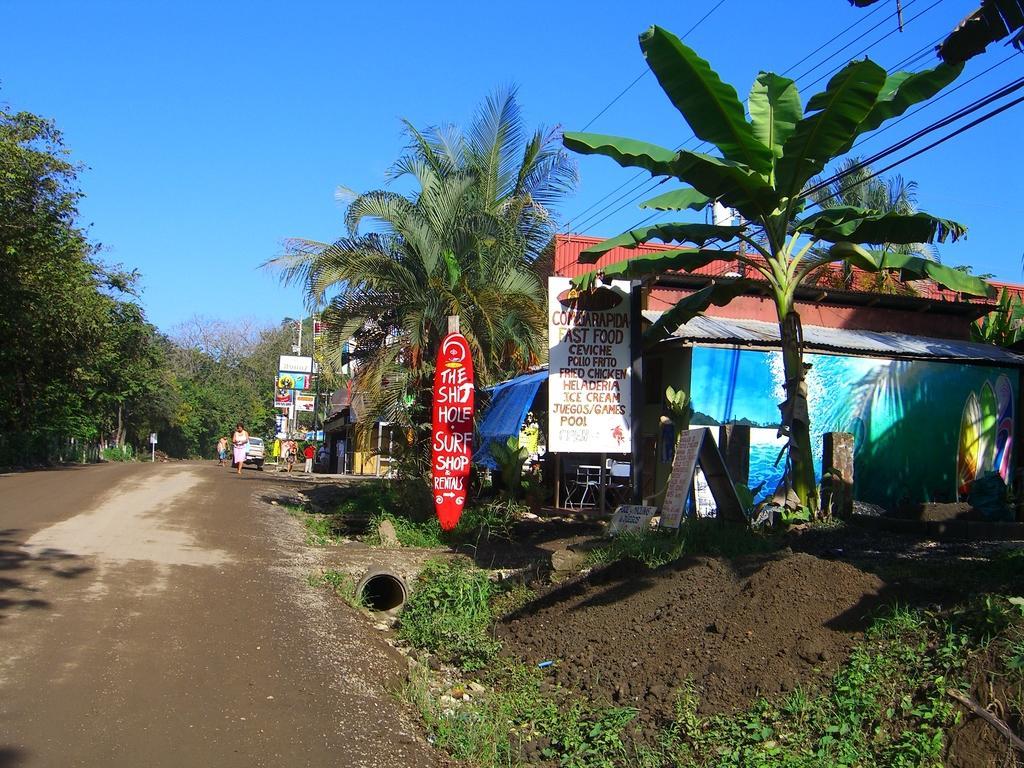How would you summarize this image in a sentence or two? In this image, I can see the name boards, trees, buildings, current wires, few people walking and a vehicle on the road. At the bottom of the image, I can see the grass. In the background, there is the sky. 